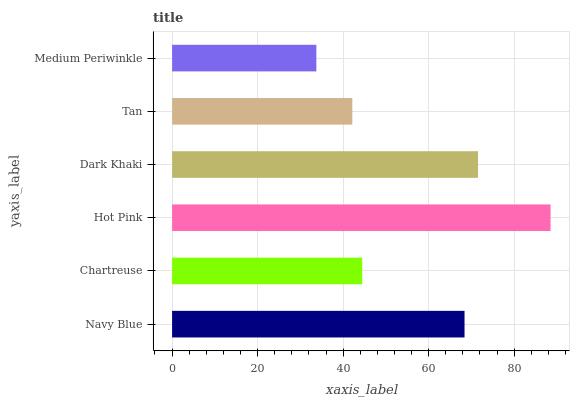Is Medium Periwinkle the minimum?
Answer yes or no. Yes. Is Hot Pink the maximum?
Answer yes or no. Yes. Is Chartreuse the minimum?
Answer yes or no. No. Is Chartreuse the maximum?
Answer yes or no. No. Is Navy Blue greater than Chartreuse?
Answer yes or no. Yes. Is Chartreuse less than Navy Blue?
Answer yes or no. Yes. Is Chartreuse greater than Navy Blue?
Answer yes or no. No. Is Navy Blue less than Chartreuse?
Answer yes or no. No. Is Navy Blue the high median?
Answer yes or no. Yes. Is Chartreuse the low median?
Answer yes or no. Yes. Is Dark Khaki the high median?
Answer yes or no. No. Is Tan the low median?
Answer yes or no. No. 